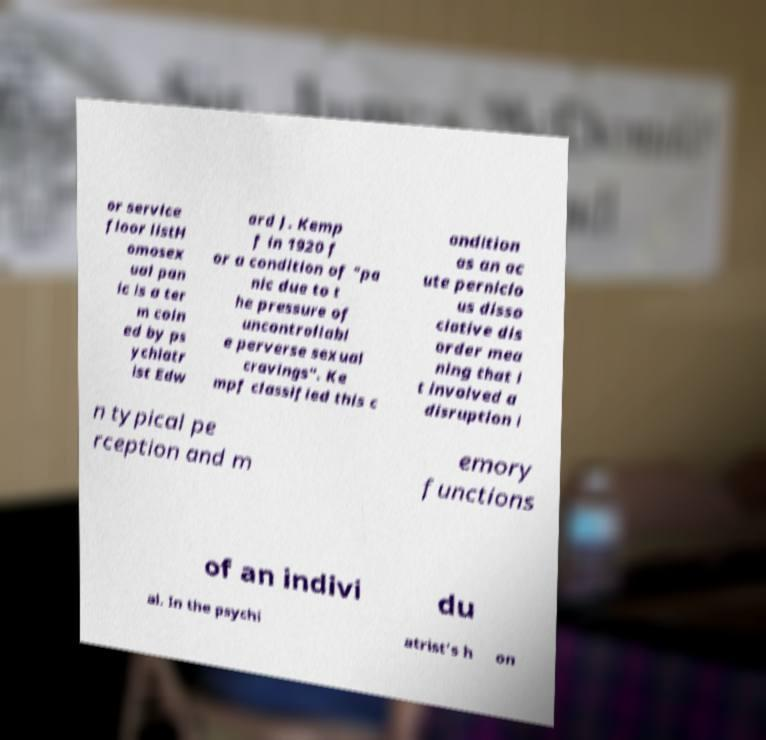Could you assist in decoding the text presented in this image and type it out clearly? or service floor listH omosex ual pan ic is a ter m coin ed by ps ychiatr ist Edw ard J. Kemp f in 1920 f or a condition of "pa nic due to t he pressure of uncontrollabl e perverse sexual cravings". Ke mpf classified this c ondition as an ac ute pernicio us disso ciative dis order mea ning that i t involved a disruption i n typical pe rception and m emory functions of an indivi du al. In the psychi atrist's h on 